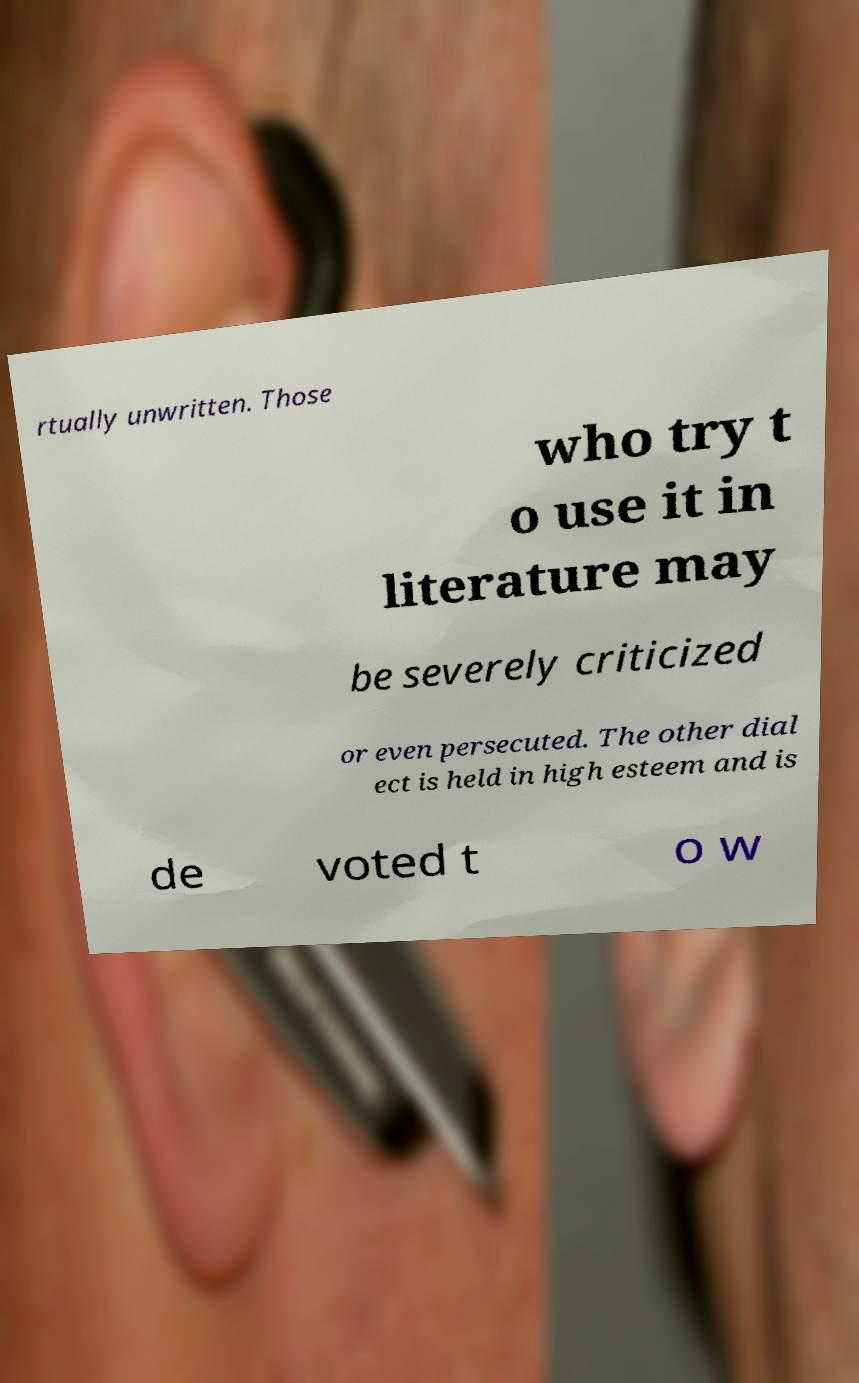What messages or text are displayed in this image? I need them in a readable, typed format. rtually unwritten. Those who try t o use it in literature may be severely criticized or even persecuted. The other dial ect is held in high esteem and is de voted t o w 